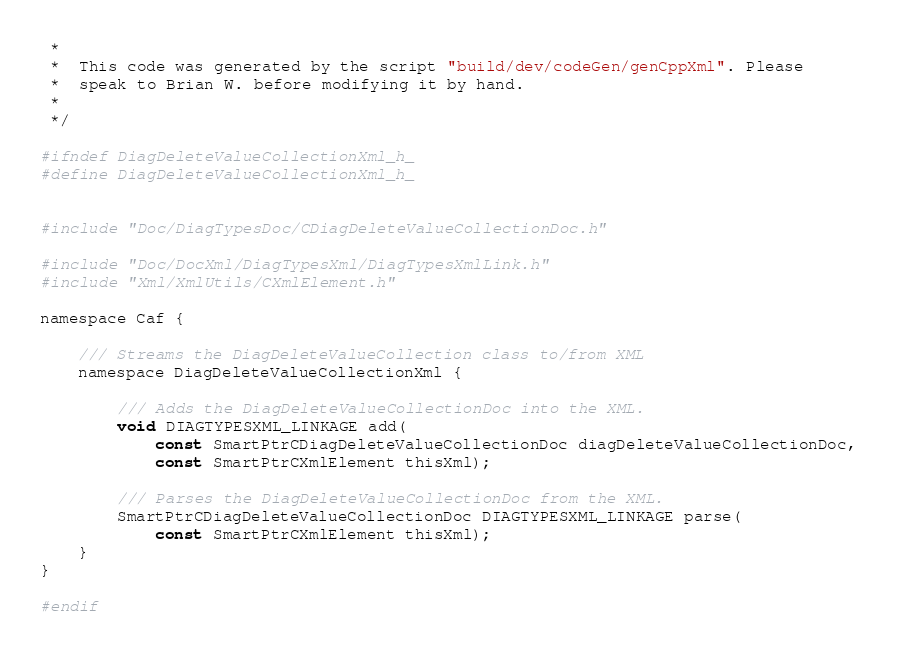Convert code to text. <code><loc_0><loc_0><loc_500><loc_500><_C_> *
 *  This code was generated by the script "build/dev/codeGen/genCppXml". Please
 *  speak to Brian W. before modifying it by hand.
 *
 */

#ifndef DiagDeleteValueCollectionXml_h_
#define DiagDeleteValueCollectionXml_h_


#include "Doc/DiagTypesDoc/CDiagDeleteValueCollectionDoc.h"

#include "Doc/DocXml/DiagTypesXml/DiagTypesXmlLink.h"
#include "Xml/XmlUtils/CXmlElement.h"

namespace Caf {

	/// Streams the DiagDeleteValueCollection class to/from XML
	namespace DiagDeleteValueCollectionXml {

		/// Adds the DiagDeleteValueCollectionDoc into the XML.
		void DIAGTYPESXML_LINKAGE add(
			const SmartPtrCDiagDeleteValueCollectionDoc diagDeleteValueCollectionDoc,
			const SmartPtrCXmlElement thisXml);

		/// Parses the DiagDeleteValueCollectionDoc from the XML.
		SmartPtrCDiagDeleteValueCollectionDoc DIAGTYPESXML_LINKAGE parse(
			const SmartPtrCXmlElement thisXml);
	}
}

#endif
</code> 